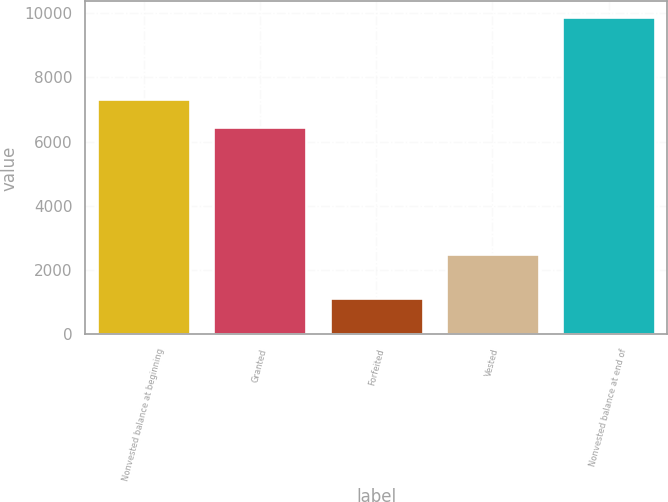Convert chart to OTSL. <chart><loc_0><loc_0><loc_500><loc_500><bar_chart><fcel>Nonvested balance at beginning<fcel>Granted<fcel>Forfeited<fcel>Vested<fcel>Nonvested balance at end of<nl><fcel>7319.3<fcel>6445<fcel>1124<fcel>2516<fcel>9867<nl></chart> 